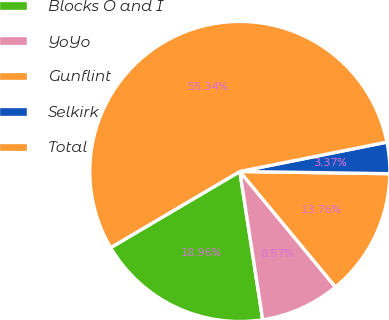<chart> <loc_0><loc_0><loc_500><loc_500><pie_chart><fcel>Blocks O and I<fcel>YoYo<fcel>Gunflint<fcel>Selkirk<fcel>Total<nl><fcel>18.96%<fcel>8.57%<fcel>13.76%<fcel>3.37%<fcel>55.34%<nl></chart> 